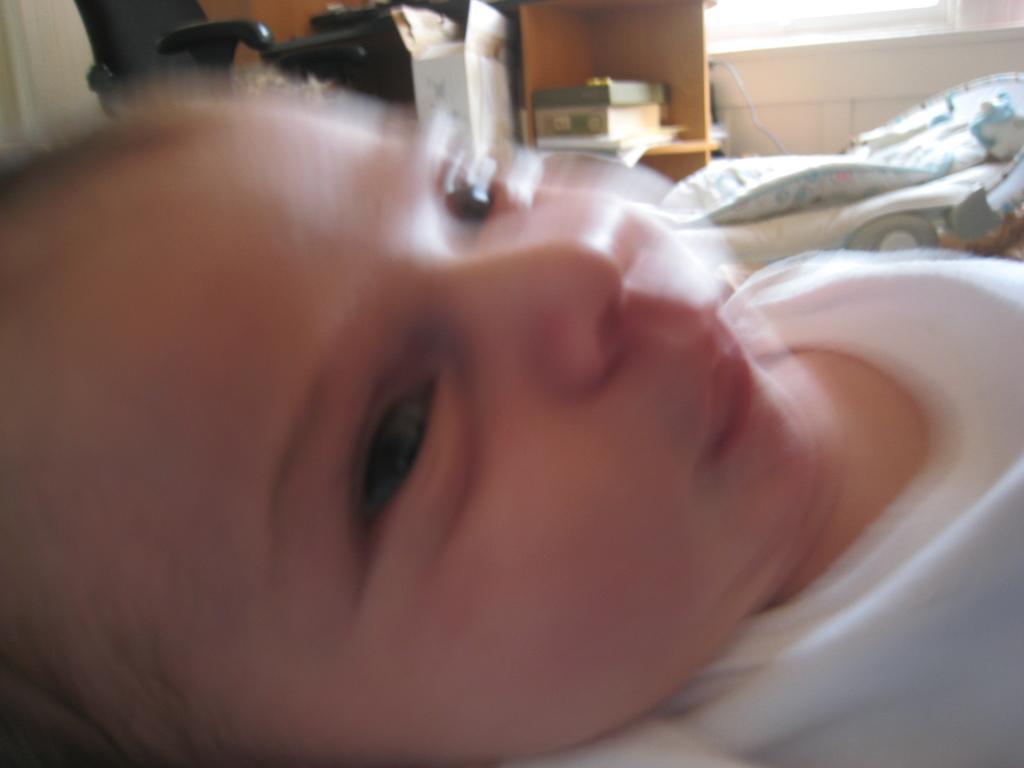How would you summarize this image in a sentence or two? In this image I can see a baby wearing white color dress and lying. In the background, I can see a bed, rack in which some objects are placed. Beside the rock there is a chair. On the right top of the image I can see a window. 